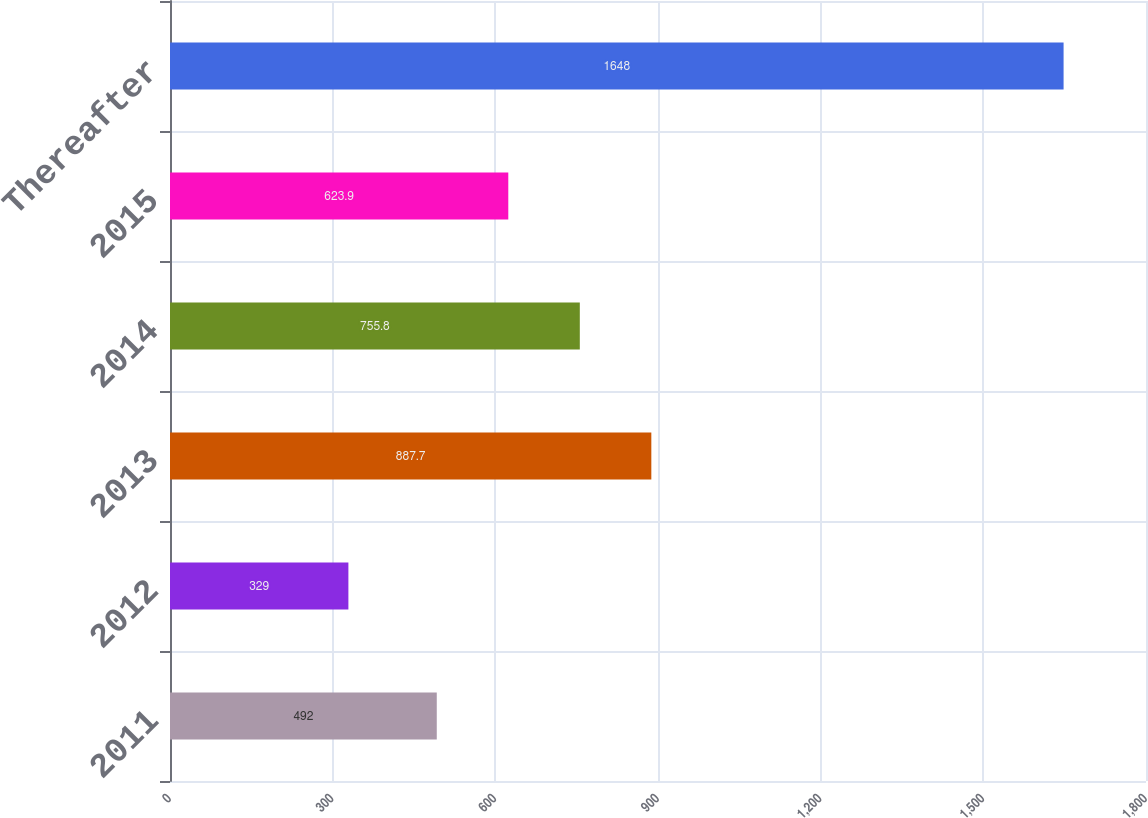Convert chart. <chart><loc_0><loc_0><loc_500><loc_500><bar_chart><fcel>2011<fcel>2012<fcel>2013<fcel>2014<fcel>2015<fcel>Thereafter<nl><fcel>492<fcel>329<fcel>887.7<fcel>755.8<fcel>623.9<fcel>1648<nl></chart> 